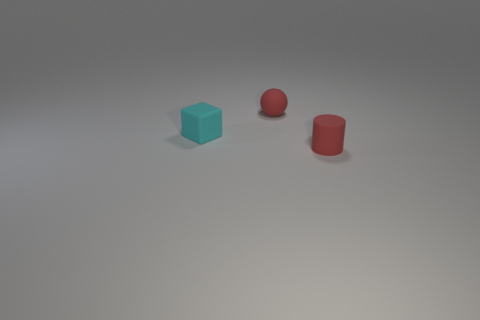Add 3 tiny rubber objects. How many objects exist? 6 Subtract all spheres. How many objects are left? 2 Subtract 1 cylinders. How many cylinders are left? 0 Subtract all brown cylinders. Subtract all yellow spheres. How many cylinders are left? 1 Subtract all blue metal things. Subtract all rubber blocks. How many objects are left? 2 Add 3 small red things. How many small red things are left? 5 Add 1 tiny cyan cylinders. How many tiny cyan cylinders exist? 1 Subtract 1 red cylinders. How many objects are left? 2 